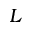<formula> <loc_0><loc_0><loc_500><loc_500>L</formula> 